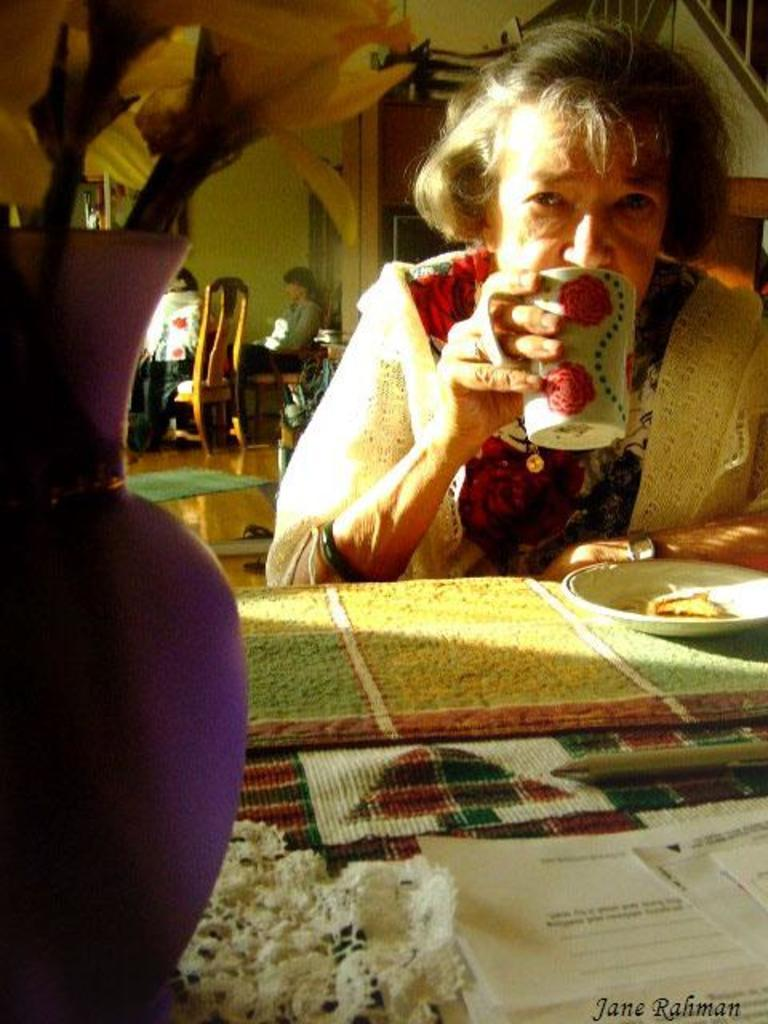Who is the main subject in the image? There is a woman in the image. What is the woman doing in the image? The woman is drinking from a cup. What objects can be seen on the table in the image? There is a flower vase, a plate, and papers on the table. What can be seen in the background of the image? There is a wall and people sitting on chairs in the background. What type of game is being played by the woman in the image? There is no game being played in the image; the woman is simply drinking from a cup. 